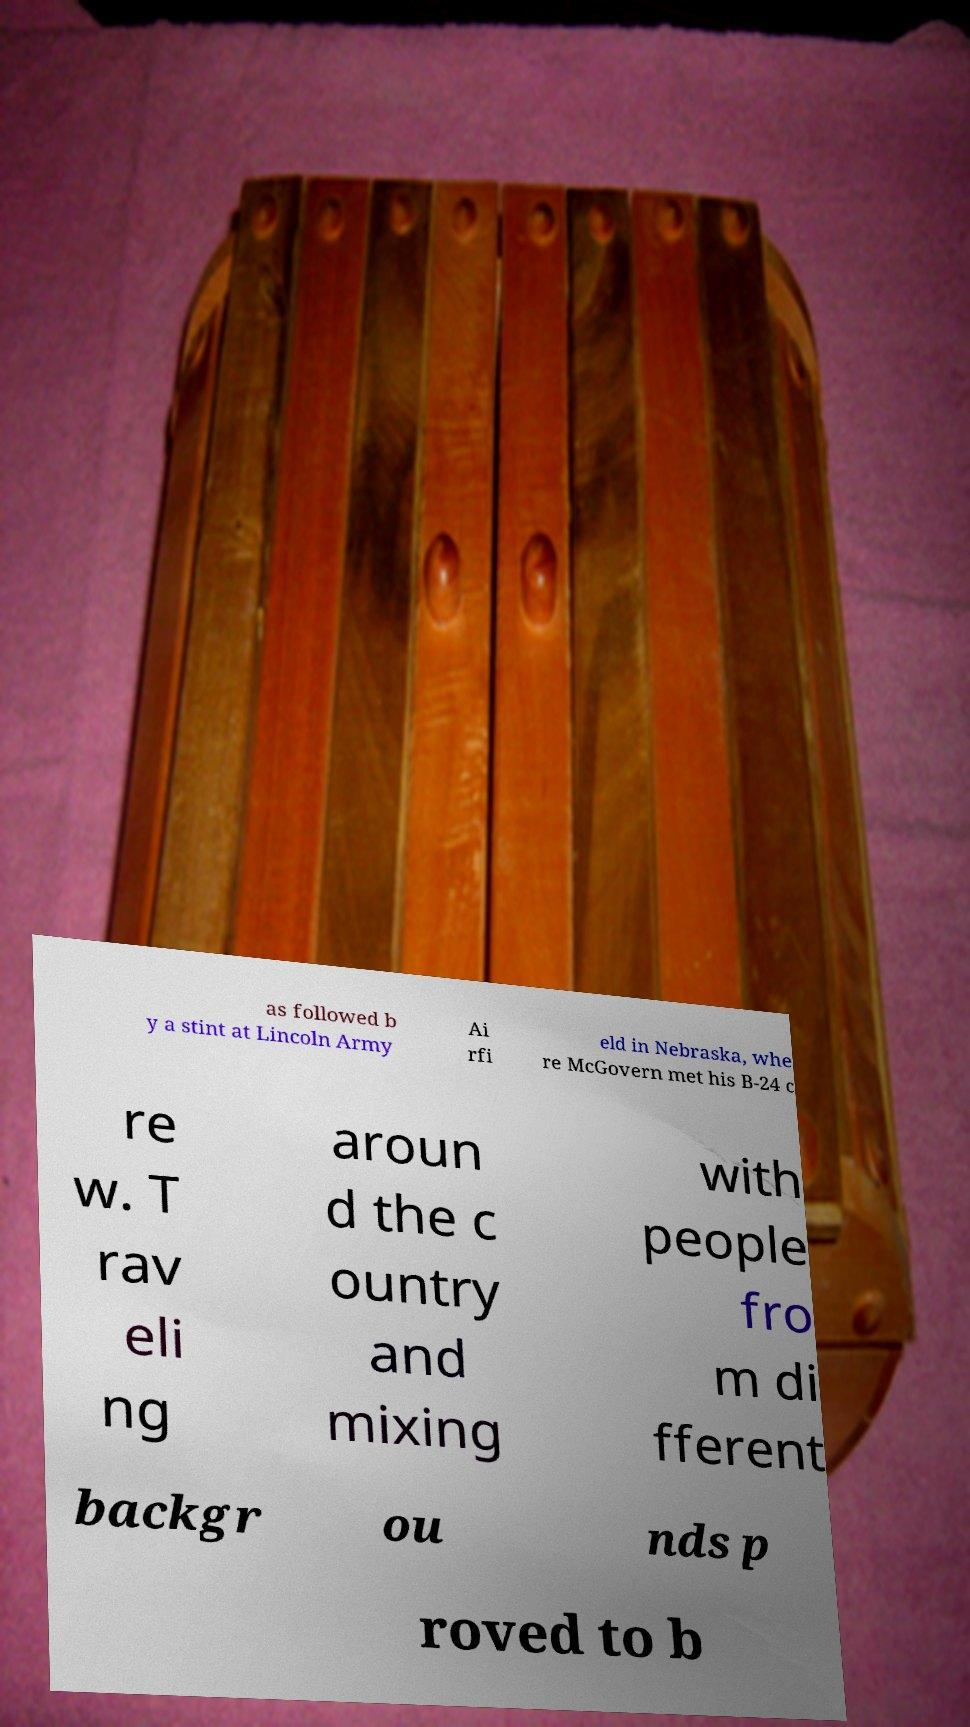Can you read and provide the text displayed in the image?This photo seems to have some interesting text. Can you extract and type it out for me? as followed b y a stint at Lincoln Army Ai rfi eld in Nebraska, whe re McGovern met his B-24 c re w. T rav eli ng aroun d the c ountry and mixing with people fro m di fferent backgr ou nds p roved to b 